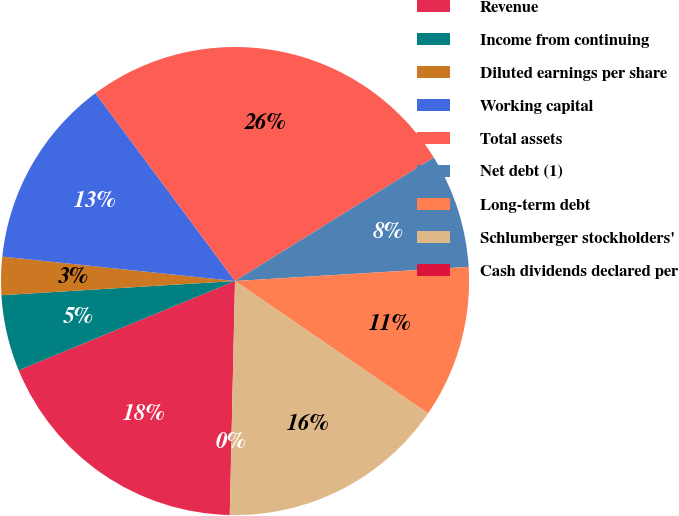Convert chart to OTSL. <chart><loc_0><loc_0><loc_500><loc_500><pie_chart><fcel>Revenue<fcel>Income from continuing<fcel>Diluted earnings per share<fcel>Working capital<fcel>Total assets<fcel>Net debt (1)<fcel>Long-term debt<fcel>Schlumberger stockholders'<fcel>Cash dividends declared per<nl><fcel>18.42%<fcel>5.26%<fcel>2.63%<fcel>13.16%<fcel>26.32%<fcel>7.89%<fcel>10.53%<fcel>15.79%<fcel>0.0%<nl></chart> 